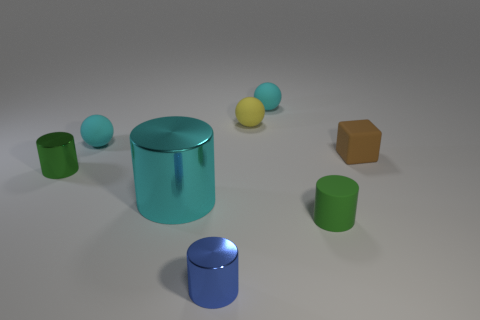There is a small metal cylinder in front of the green shiny object; is it the same color as the thing to the right of the green matte cylinder?
Offer a terse response. No. Are there any other things that have the same size as the cyan metallic cylinder?
Ensure brevity in your answer.  No. Are there any small yellow spheres in front of the brown thing?
Keep it short and to the point. No. How many other tiny metal objects have the same shape as the brown thing?
Your answer should be compact. 0. The cylinder that is on the right side of the tiny shiny cylinder in front of the tiny green cylinder left of the small green rubber thing is what color?
Your answer should be compact. Green. Does the cylinder on the left side of the cyan metal cylinder have the same material as the cyan object in front of the cube?
Your answer should be compact. Yes. What number of things are either matte things that are right of the tiny blue shiny cylinder or big gray rubber spheres?
Give a very brief answer. 4. What number of things are either big blue spheres or tiny rubber things behind the brown matte cube?
Ensure brevity in your answer.  3. How many yellow things have the same size as the green metal cylinder?
Offer a very short reply. 1. Is the number of small blue cylinders to the left of the large cyan cylinder less than the number of matte cylinders that are left of the tiny blue cylinder?
Your answer should be very brief. No. 